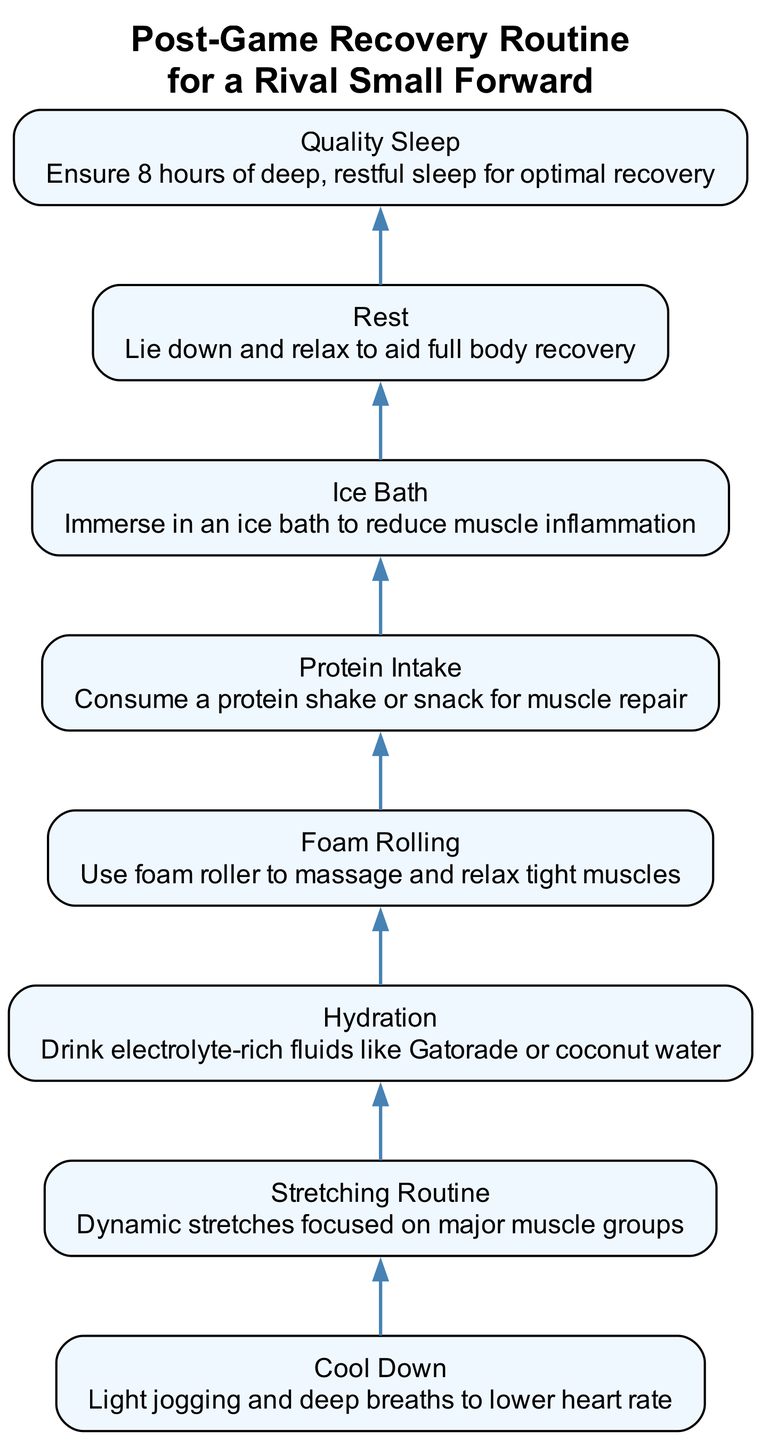What is the first step in the recovery routine? The diagram indicates that the first step, at the bottom, is "Cool Down." This is the starting point of the post-game recovery process.
Answer: Cool Down How many steps are in the recovery routine? By counting all the steps outlined in the diagram, there are a total of eight distinct steps in the recovery routine.
Answer: 8 What follows Hydration in the flow chart? According to the flow of the diagram, "Foam Rolling" is the step that comes directly after "Hydration," indicating the order of recovery activities.
Answer: Foam Rolling What is the last step in the recovery process? Reviewing the diagram, the last step at the top is labeled "Quality Sleep," signifying its importance in completing the recovery routine.
Answer: Quality Sleep Which step involves drinking fluids? The step labeled "Hydration" specifically mentions the action of drinking fluids, indicating its focus on maintaining fluid balance post-activity.
Answer: Hydration What steps are focused on muscle recovery? The steps "Foam Rolling" and "Protein Intake" both relate to muscle recovery by addressing both muscle relaxation and repair post-exercise.
Answer: Foam Rolling, Protein Intake Which two steps are directly linked? The step "Stretching Routine" is directly followed by "Hydration," showing a connection in the flow indicating that stretching leads into hydration needs.
Answer: Stretching Routine and Hydration What is the purpose of the Ice Bath step? The description of the "Ice Bath" step explains its purpose as a method to "reduce muscle inflammation," which is crucial for recovery after intense physical activity.
Answer: Reduce muscle inflammation 